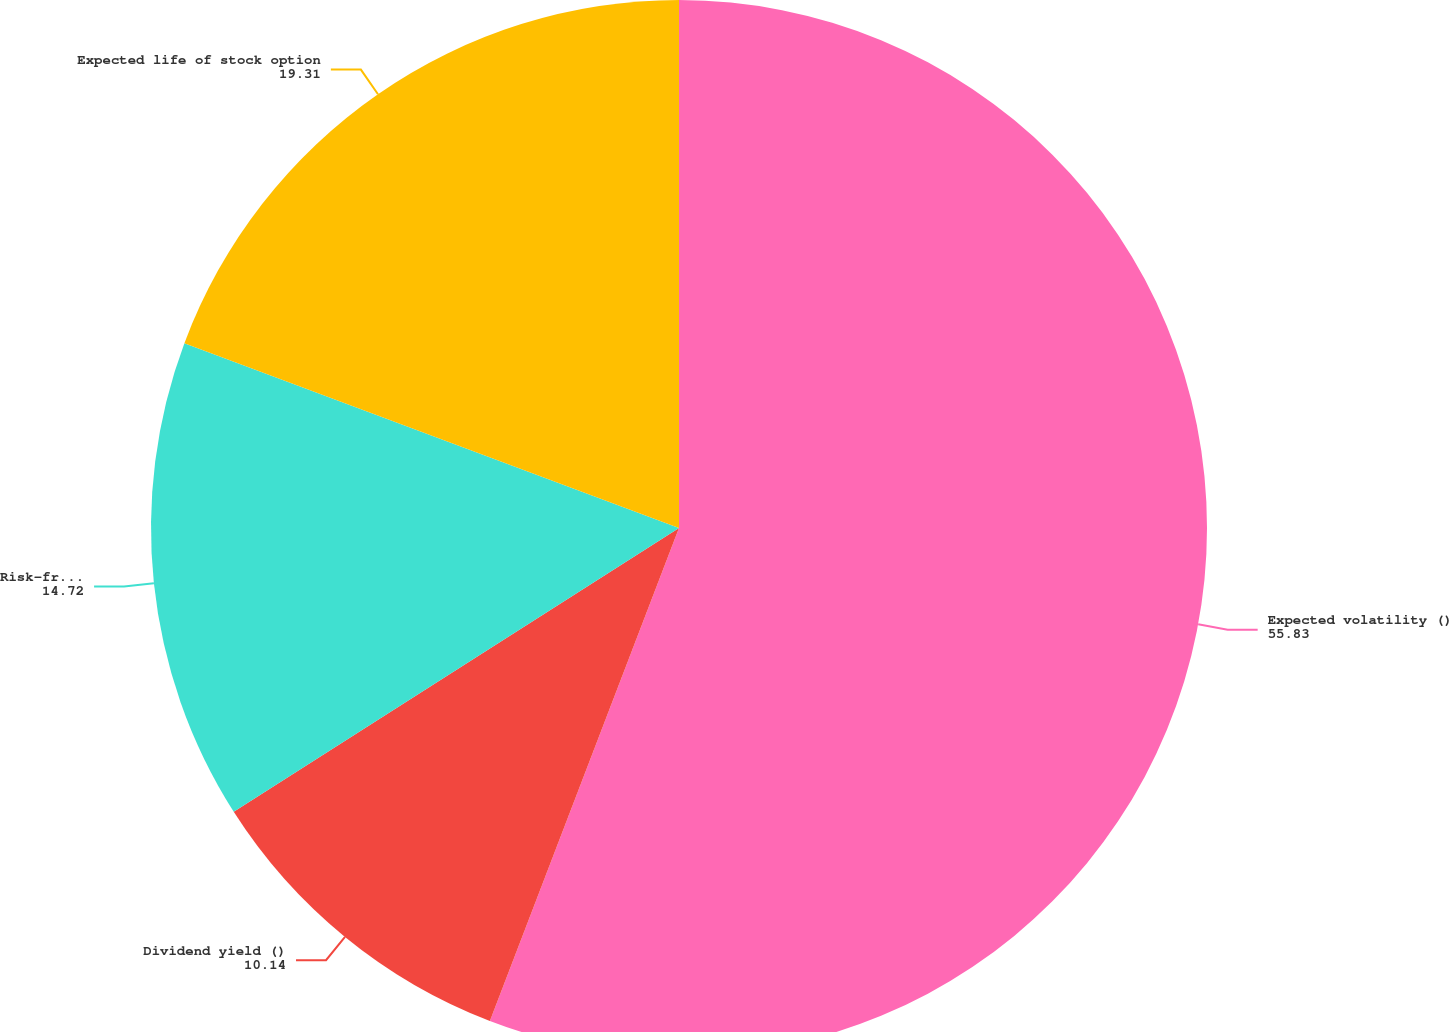<chart> <loc_0><loc_0><loc_500><loc_500><pie_chart><fcel>Expected volatility ()<fcel>Dividend yield ()<fcel>Risk-free interest rates ()<fcel>Expected life of stock option<nl><fcel>55.83%<fcel>10.14%<fcel>14.72%<fcel>19.31%<nl></chart> 